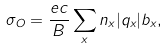Convert formula to latex. <formula><loc_0><loc_0><loc_500><loc_500>\sigma _ { O } = \frac { e c } { B } \sum _ { x } n _ { x } | q _ { x } | b _ { x } ,</formula> 